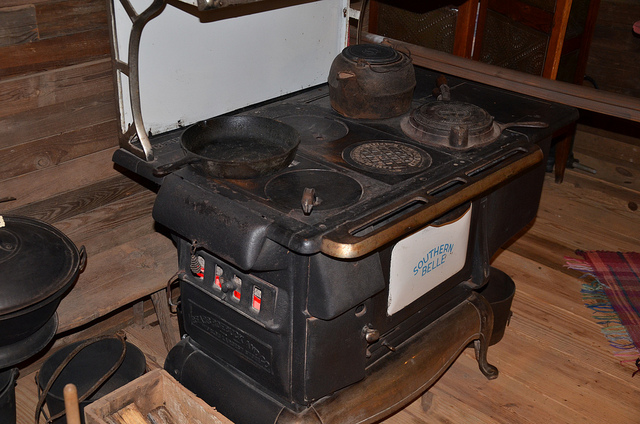<image>What does the oven say on the side? The oven might say "southern belle" on the side, but I'm not completely certain. What does the oven say on the side? The oven says 'southern belle' on the side. 